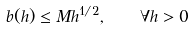<formula> <loc_0><loc_0><loc_500><loc_500>b ( h ) \leq M h ^ { 1 / 2 } , \quad \forall h > 0</formula> 